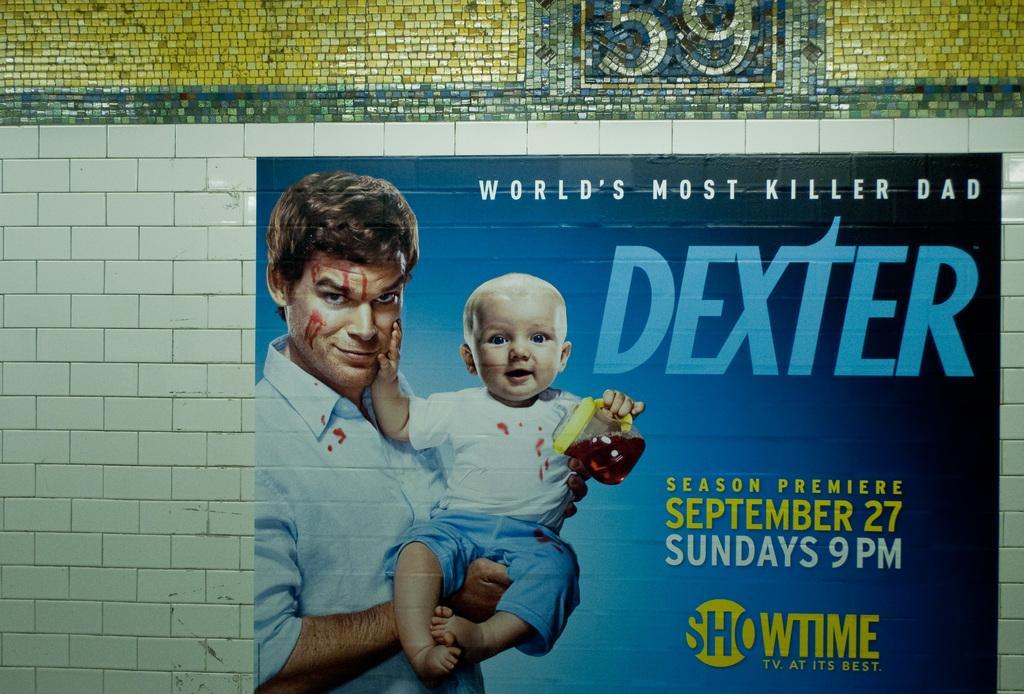In one or two sentences, can you explain what this image depicts? In this picture we can see a painting on the wall, in the painting we can see a man and a kid. 